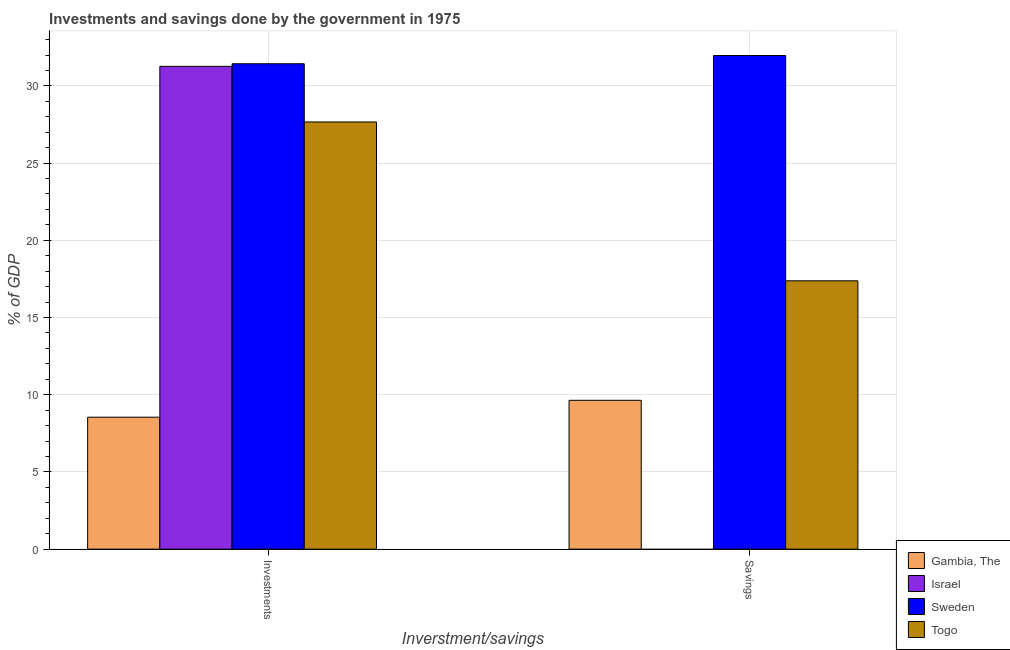How many groups of bars are there?
Ensure brevity in your answer.  2. How many bars are there on the 2nd tick from the right?
Offer a very short reply. 4. What is the label of the 1st group of bars from the left?
Your answer should be very brief. Investments. What is the investments of government in Israel?
Ensure brevity in your answer.  31.27. Across all countries, what is the maximum investments of government?
Offer a terse response. 31.43. In which country was the investments of government maximum?
Your response must be concise. Sweden. What is the total savings of government in the graph?
Give a very brief answer. 58.98. What is the difference between the savings of government in Sweden and that in Gambia, The?
Provide a succinct answer. 22.33. What is the difference between the savings of government in Israel and the investments of government in Sweden?
Make the answer very short. -31.43. What is the average investments of government per country?
Give a very brief answer. 24.73. What is the difference between the savings of government and investments of government in Sweden?
Provide a succinct answer. 0.53. In how many countries, is the investments of government greater than 31 %?
Your response must be concise. 2. What is the ratio of the investments of government in Israel to that in Sweden?
Give a very brief answer. 0.99. In how many countries, is the investments of government greater than the average investments of government taken over all countries?
Provide a succinct answer. 3. Are all the bars in the graph horizontal?
Make the answer very short. No. How many countries are there in the graph?
Offer a very short reply. 4. What is the difference between two consecutive major ticks on the Y-axis?
Offer a very short reply. 5. Are the values on the major ticks of Y-axis written in scientific E-notation?
Offer a very short reply. No. Does the graph contain any zero values?
Offer a terse response. Yes. Does the graph contain grids?
Offer a very short reply. Yes. How many legend labels are there?
Offer a very short reply. 4. What is the title of the graph?
Keep it short and to the point. Investments and savings done by the government in 1975. What is the label or title of the X-axis?
Provide a succinct answer. Inverstment/savings. What is the label or title of the Y-axis?
Provide a succinct answer. % of GDP. What is the % of GDP in Gambia, The in Investments?
Make the answer very short. 8.55. What is the % of GDP in Israel in Investments?
Your answer should be compact. 31.27. What is the % of GDP in Sweden in Investments?
Ensure brevity in your answer.  31.43. What is the % of GDP of Togo in Investments?
Ensure brevity in your answer.  27.66. What is the % of GDP in Gambia, The in Savings?
Your response must be concise. 9.64. What is the % of GDP of Sweden in Savings?
Provide a succinct answer. 31.97. What is the % of GDP of Togo in Savings?
Give a very brief answer. 17.38. Across all Inverstment/savings, what is the maximum % of GDP of Gambia, The?
Offer a terse response. 9.64. Across all Inverstment/savings, what is the maximum % of GDP in Israel?
Offer a very short reply. 31.27. Across all Inverstment/savings, what is the maximum % of GDP of Sweden?
Your answer should be compact. 31.97. Across all Inverstment/savings, what is the maximum % of GDP of Togo?
Your answer should be very brief. 27.66. Across all Inverstment/savings, what is the minimum % of GDP in Gambia, The?
Ensure brevity in your answer.  8.55. Across all Inverstment/savings, what is the minimum % of GDP of Israel?
Offer a terse response. 0. Across all Inverstment/savings, what is the minimum % of GDP in Sweden?
Your answer should be compact. 31.43. Across all Inverstment/savings, what is the minimum % of GDP in Togo?
Provide a succinct answer. 17.38. What is the total % of GDP in Gambia, The in the graph?
Provide a succinct answer. 18.18. What is the total % of GDP in Israel in the graph?
Offer a very short reply. 31.27. What is the total % of GDP of Sweden in the graph?
Keep it short and to the point. 63.4. What is the total % of GDP of Togo in the graph?
Ensure brevity in your answer.  45.04. What is the difference between the % of GDP in Gambia, The in Investments and that in Savings?
Keep it short and to the point. -1.09. What is the difference between the % of GDP in Sweden in Investments and that in Savings?
Offer a terse response. -0.53. What is the difference between the % of GDP in Togo in Investments and that in Savings?
Your response must be concise. 10.29. What is the difference between the % of GDP in Gambia, The in Investments and the % of GDP in Sweden in Savings?
Give a very brief answer. -23.42. What is the difference between the % of GDP of Gambia, The in Investments and the % of GDP of Togo in Savings?
Your answer should be very brief. -8.83. What is the difference between the % of GDP of Israel in Investments and the % of GDP of Sweden in Savings?
Your answer should be compact. -0.7. What is the difference between the % of GDP of Israel in Investments and the % of GDP of Togo in Savings?
Offer a terse response. 13.89. What is the difference between the % of GDP of Sweden in Investments and the % of GDP of Togo in Savings?
Your answer should be very brief. 14.06. What is the average % of GDP of Gambia, The per Inverstment/savings?
Offer a very short reply. 9.09. What is the average % of GDP in Israel per Inverstment/savings?
Your answer should be very brief. 15.63. What is the average % of GDP in Sweden per Inverstment/savings?
Make the answer very short. 31.7. What is the average % of GDP of Togo per Inverstment/savings?
Your response must be concise. 22.52. What is the difference between the % of GDP in Gambia, The and % of GDP in Israel in Investments?
Provide a short and direct response. -22.72. What is the difference between the % of GDP of Gambia, The and % of GDP of Sweden in Investments?
Ensure brevity in your answer.  -22.89. What is the difference between the % of GDP of Gambia, The and % of GDP of Togo in Investments?
Offer a very short reply. -19.12. What is the difference between the % of GDP in Israel and % of GDP in Sweden in Investments?
Offer a terse response. -0.17. What is the difference between the % of GDP of Israel and % of GDP of Togo in Investments?
Your answer should be very brief. 3.6. What is the difference between the % of GDP of Sweden and % of GDP of Togo in Investments?
Ensure brevity in your answer.  3.77. What is the difference between the % of GDP in Gambia, The and % of GDP in Sweden in Savings?
Offer a terse response. -22.33. What is the difference between the % of GDP of Gambia, The and % of GDP of Togo in Savings?
Offer a terse response. -7.74. What is the difference between the % of GDP in Sweden and % of GDP in Togo in Savings?
Give a very brief answer. 14.59. What is the ratio of the % of GDP of Gambia, The in Investments to that in Savings?
Provide a short and direct response. 0.89. What is the ratio of the % of GDP of Sweden in Investments to that in Savings?
Give a very brief answer. 0.98. What is the ratio of the % of GDP in Togo in Investments to that in Savings?
Your answer should be very brief. 1.59. What is the difference between the highest and the second highest % of GDP in Gambia, The?
Make the answer very short. 1.09. What is the difference between the highest and the second highest % of GDP in Sweden?
Ensure brevity in your answer.  0.53. What is the difference between the highest and the second highest % of GDP of Togo?
Make the answer very short. 10.29. What is the difference between the highest and the lowest % of GDP of Gambia, The?
Your answer should be very brief. 1.09. What is the difference between the highest and the lowest % of GDP in Israel?
Give a very brief answer. 31.27. What is the difference between the highest and the lowest % of GDP of Sweden?
Offer a very short reply. 0.53. What is the difference between the highest and the lowest % of GDP in Togo?
Your answer should be very brief. 10.29. 